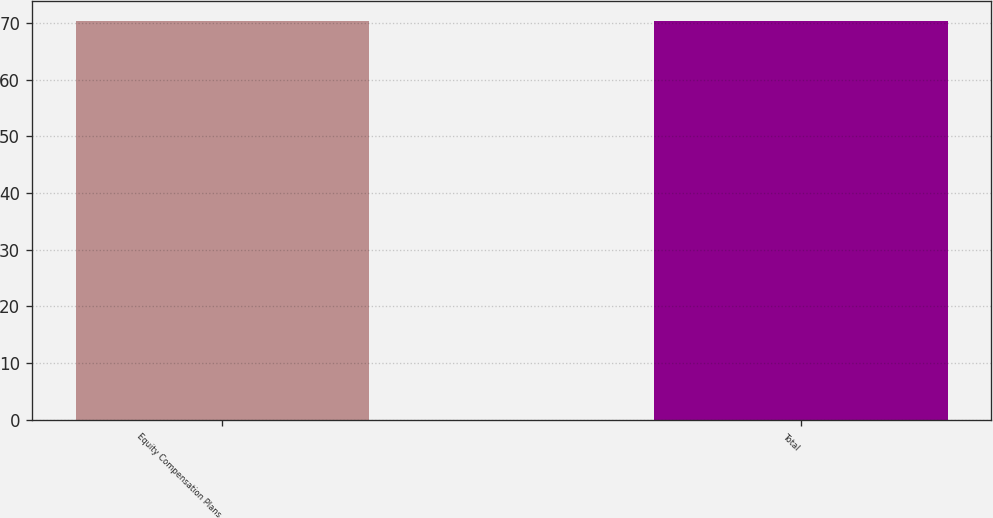<chart> <loc_0><loc_0><loc_500><loc_500><bar_chart><fcel>Equity Compensation Plans<fcel>Total<nl><fcel>70.27<fcel>70.37<nl></chart> 